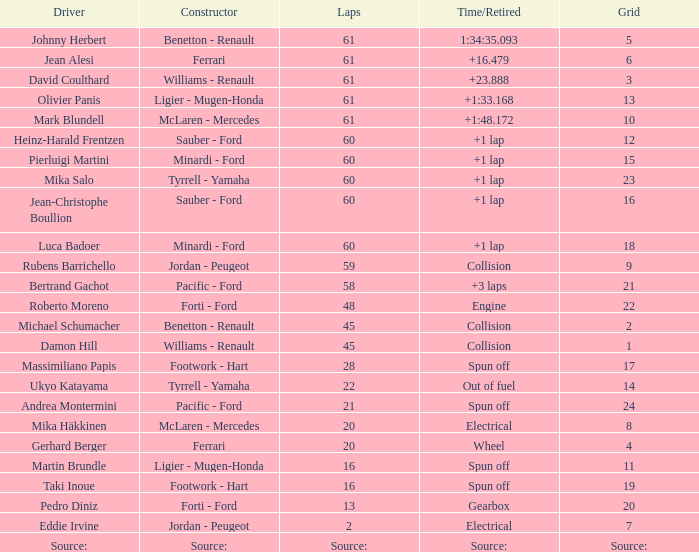How many laps does roberto moreno have? 48.0. 